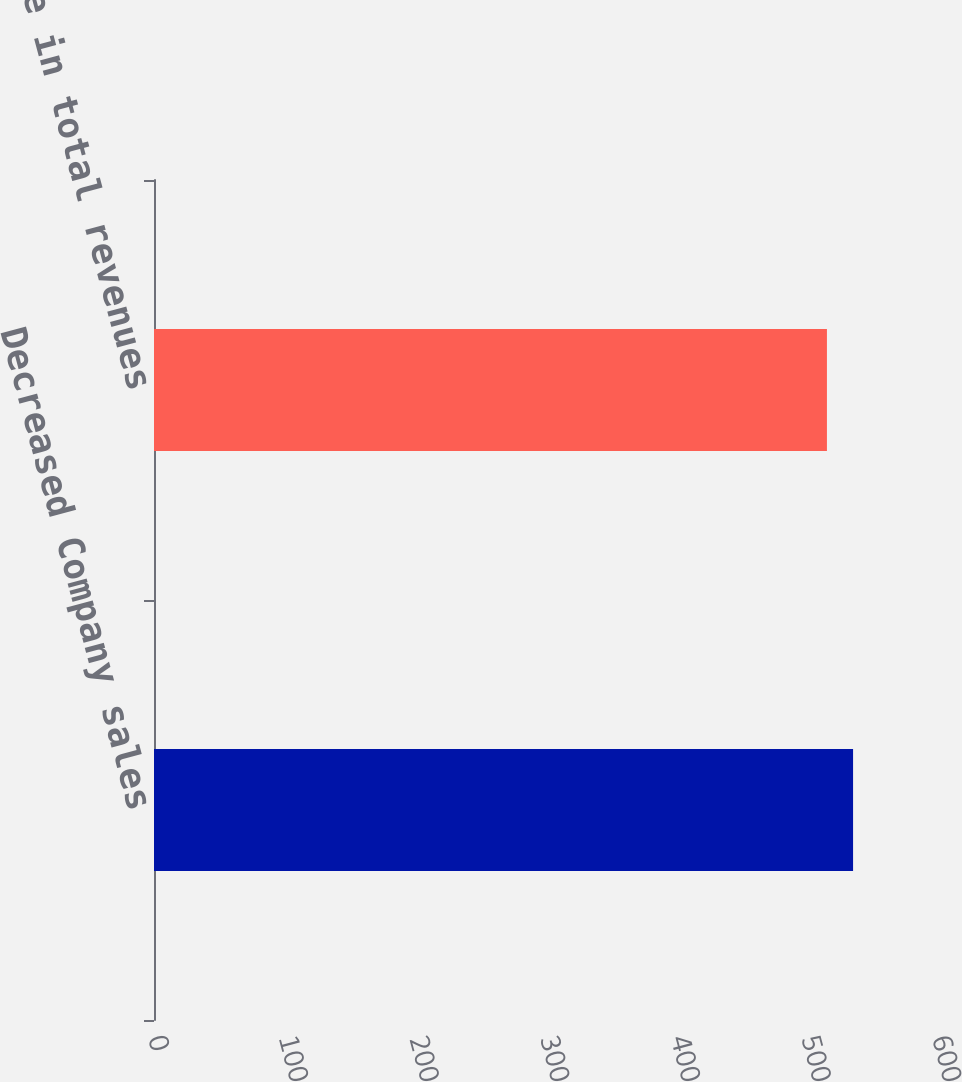Convert chart to OTSL. <chart><loc_0><loc_0><loc_500><loc_500><bar_chart><fcel>Decreased Company sales<fcel>Decrease in total revenues<nl><fcel>535<fcel>515<nl></chart> 